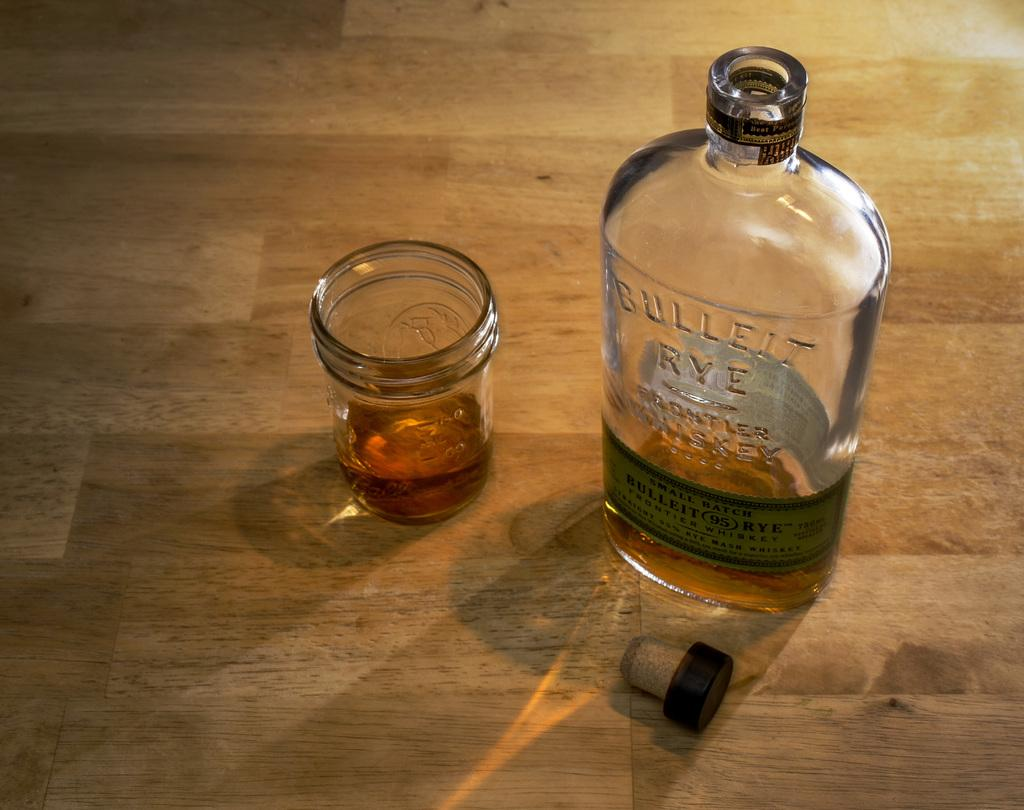What is in the bottle that is visible in the image? There is a bottle with a cork in the image. What type of container is also present in the image? There is a glass in the image. What color is the curtain behind the bottle in the image? There is no curtain present in the image. What part of the body can be seen interacting with the glass in the image? There are no body parts visible in the image; only the bottle, cork, and glass are present. 